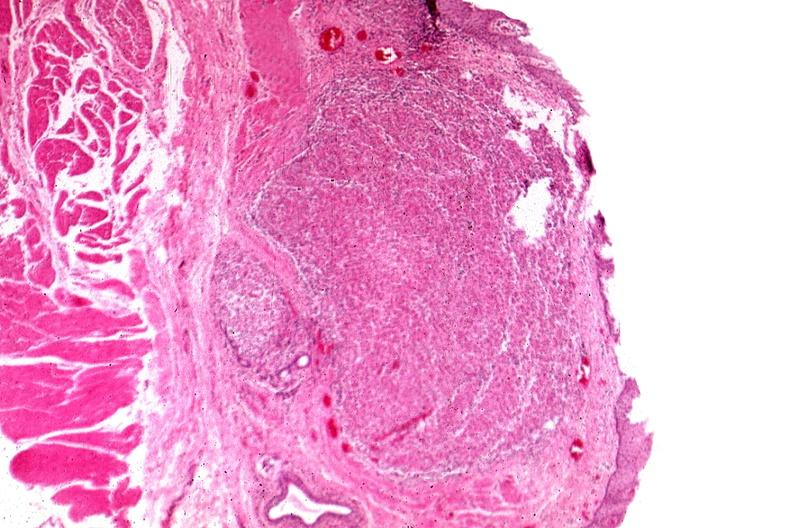what does this image show?
Answer the question using a single word or phrase. Tunica propria granulomas 